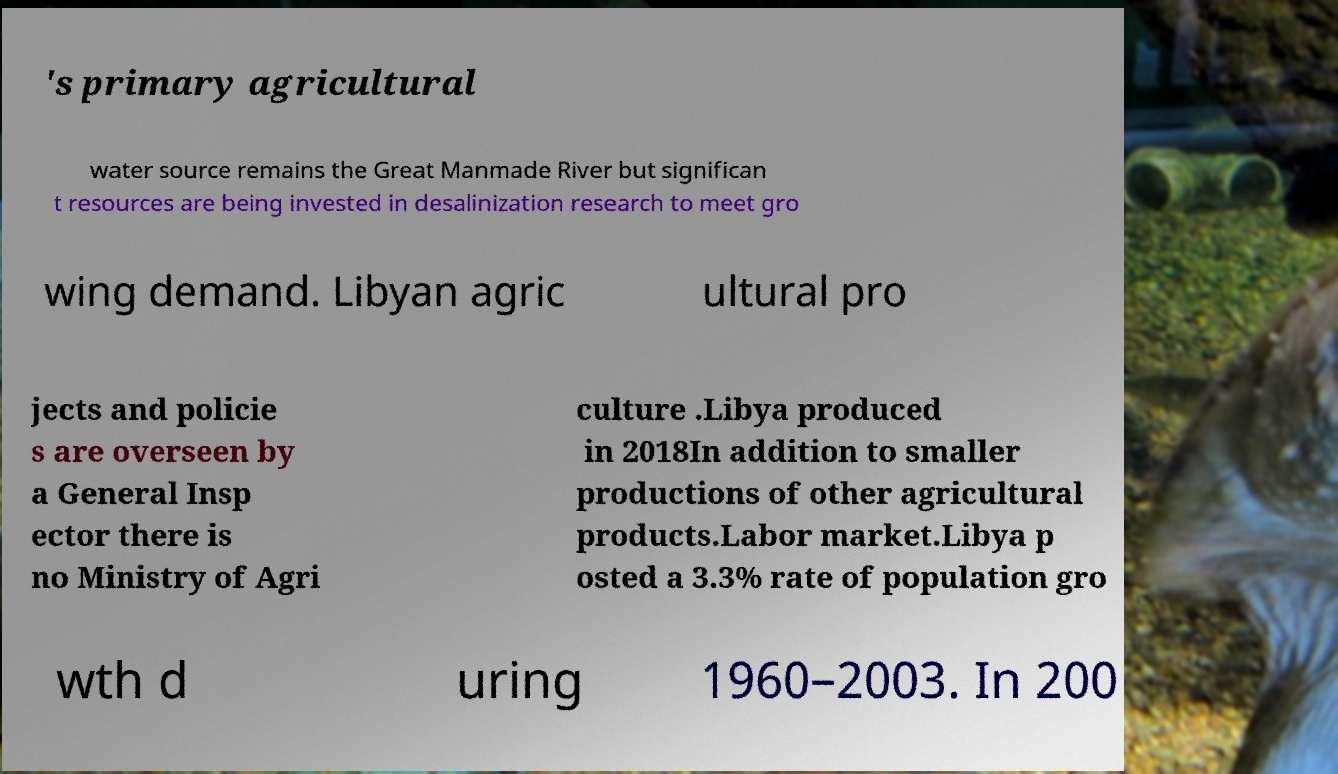Please read and relay the text visible in this image. What does it say? 's primary agricultural water source remains the Great Manmade River but significan t resources are being invested in desalinization research to meet gro wing demand. Libyan agric ultural pro jects and policie s are overseen by a General Insp ector there is no Ministry of Agri culture .Libya produced in 2018In addition to smaller productions of other agricultural products.Labor market.Libya p osted a 3.3% rate of population gro wth d uring 1960–2003. In 200 